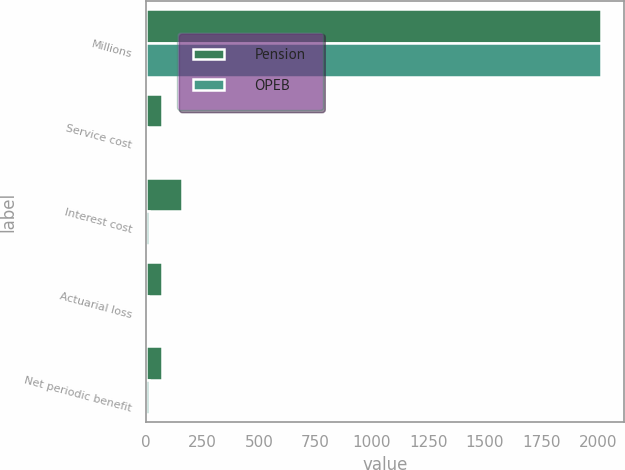<chart> <loc_0><loc_0><loc_500><loc_500><stacked_bar_chart><ecel><fcel>Millions<fcel>Service cost<fcel>Interest cost<fcel>Actuarial loss<fcel>Net periodic benefit<nl><fcel>Pension<fcel>2014<fcel>70<fcel>158<fcel>71<fcel>69<nl><fcel>OPEB<fcel>2014<fcel>2<fcel>14<fcel>10<fcel>15<nl></chart> 